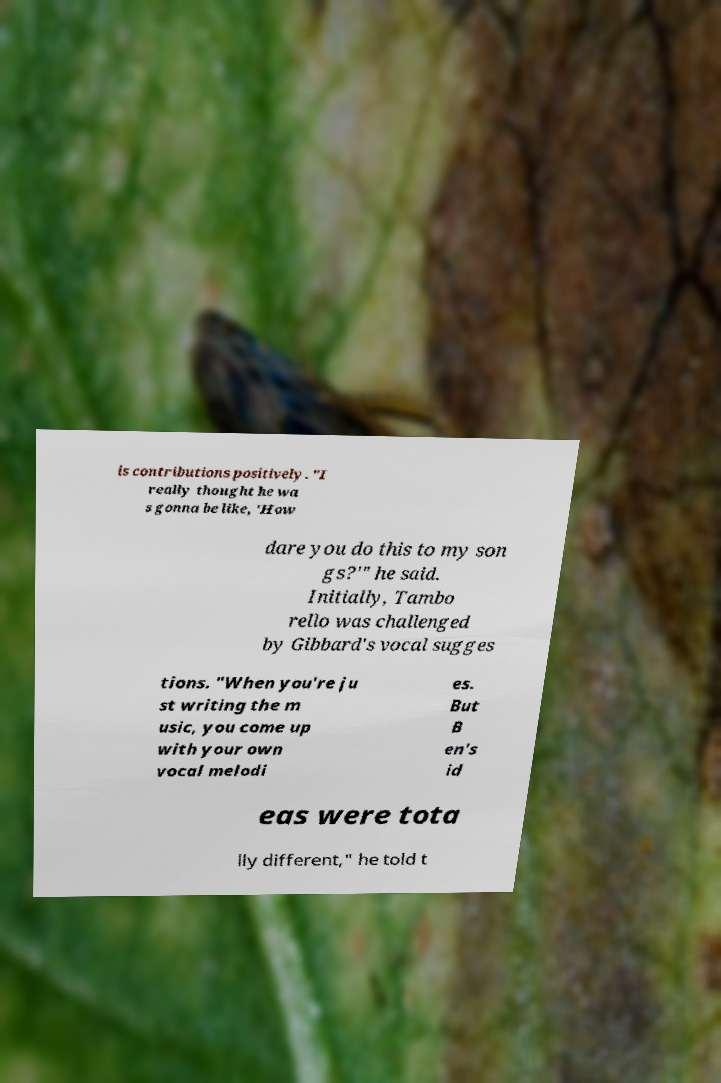Can you read and provide the text displayed in the image?This photo seems to have some interesting text. Can you extract and type it out for me? is contributions positively. "I really thought he wa s gonna be like, 'How dare you do this to my son gs?'" he said. Initially, Tambo rello was challenged by Gibbard's vocal sugges tions. "When you're ju st writing the m usic, you come up with your own vocal melodi es. But B en's id eas were tota lly different," he told t 